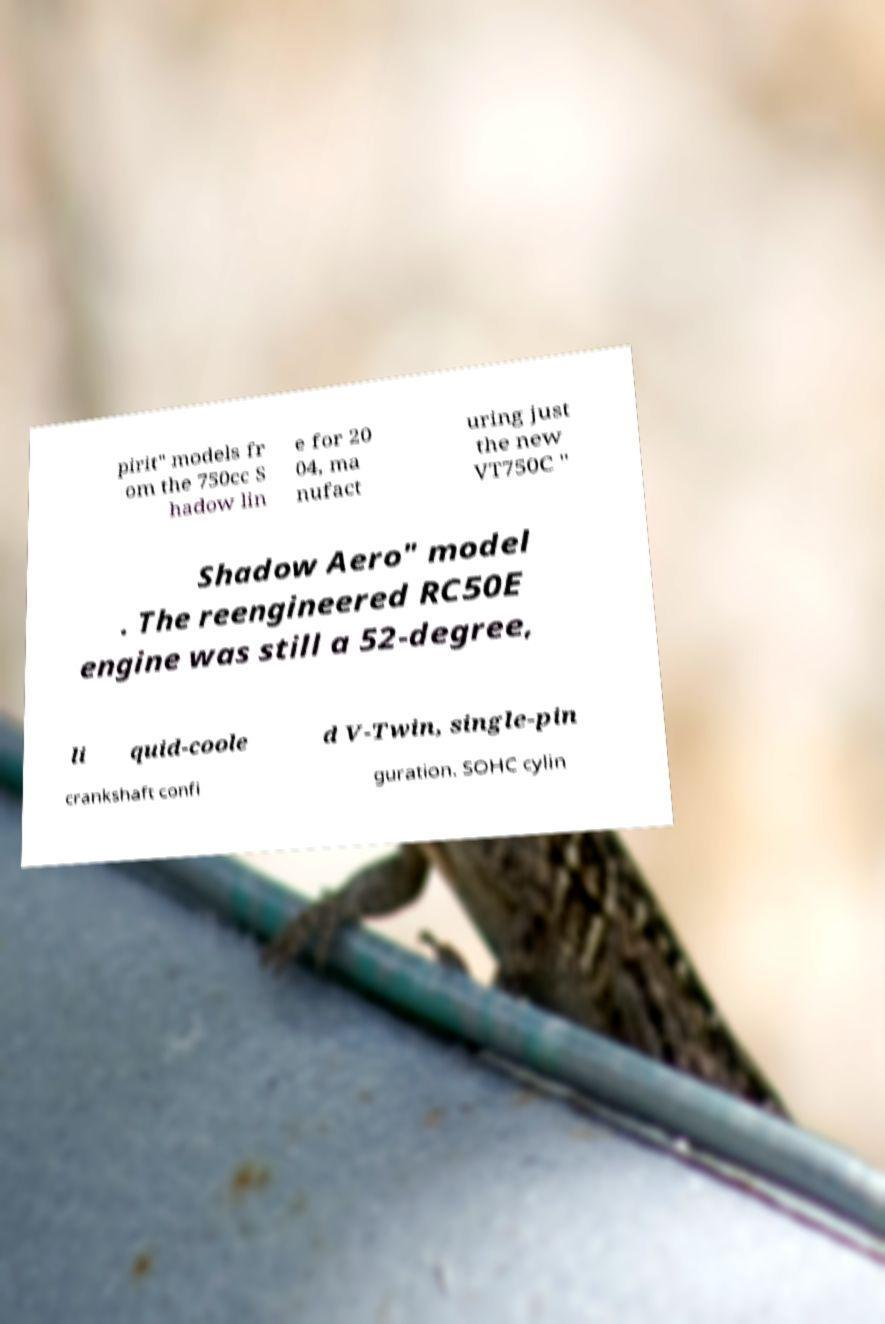Please read and relay the text visible in this image. What does it say? pirit" models fr om the 750cc S hadow lin e for 20 04, ma nufact uring just the new VT750C " Shadow Aero" model . The reengineered RC50E engine was still a 52-degree, li quid-coole d V-Twin, single-pin crankshaft confi guration. SOHC cylin 